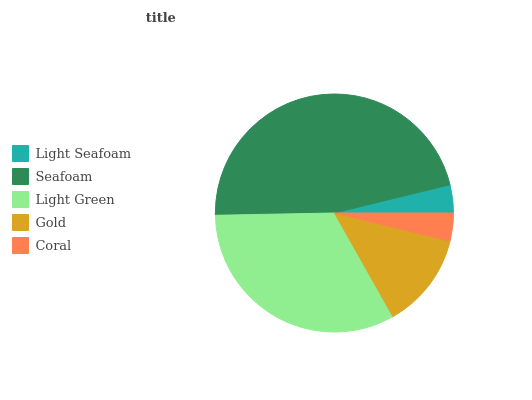Is Coral the minimum?
Answer yes or no. Yes. Is Seafoam the maximum?
Answer yes or no. Yes. Is Light Green the minimum?
Answer yes or no. No. Is Light Green the maximum?
Answer yes or no. No. Is Seafoam greater than Light Green?
Answer yes or no. Yes. Is Light Green less than Seafoam?
Answer yes or no. Yes. Is Light Green greater than Seafoam?
Answer yes or no. No. Is Seafoam less than Light Green?
Answer yes or no. No. Is Gold the high median?
Answer yes or no. Yes. Is Gold the low median?
Answer yes or no. Yes. Is Light Green the high median?
Answer yes or no. No. Is Seafoam the low median?
Answer yes or no. No. 